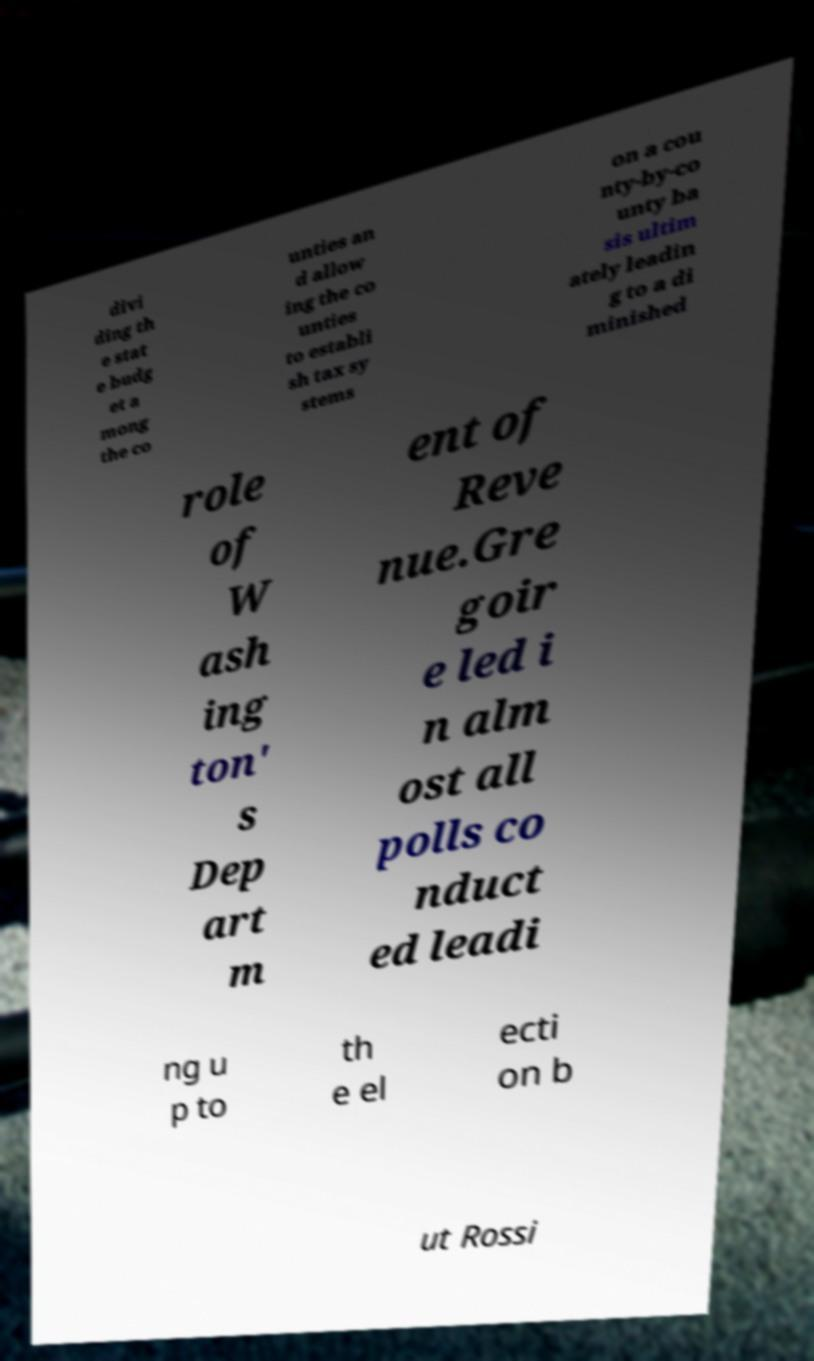What messages or text are displayed in this image? I need them in a readable, typed format. divi ding th e stat e budg et a mong the co unties an d allow ing the co unties to establi sh tax sy stems on a cou nty-by-co unty ba sis ultim ately leadin g to a di minished role of W ash ing ton' s Dep art m ent of Reve nue.Gre goir e led i n alm ost all polls co nduct ed leadi ng u p to th e el ecti on b ut Rossi 